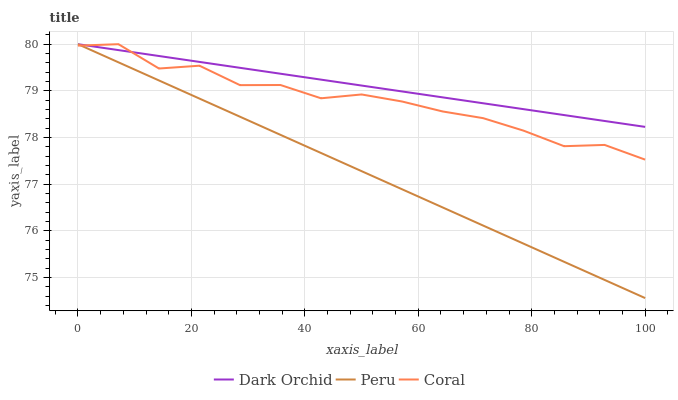Does Peru have the minimum area under the curve?
Answer yes or no. Yes. Does Dark Orchid have the maximum area under the curve?
Answer yes or no. Yes. Does Dark Orchid have the minimum area under the curve?
Answer yes or no. No. Does Peru have the maximum area under the curve?
Answer yes or no. No. Is Dark Orchid the smoothest?
Answer yes or no. Yes. Is Coral the roughest?
Answer yes or no. Yes. Is Peru the smoothest?
Answer yes or no. No. Is Peru the roughest?
Answer yes or no. No. Does Peru have the lowest value?
Answer yes or no. Yes. Does Dark Orchid have the lowest value?
Answer yes or no. No. Does Dark Orchid have the highest value?
Answer yes or no. Yes. Does Dark Orchid intersect Peru?
Answer yes or no. Yes. Is Dark Orchid less than Peru?
Answer yes or no. No. Is Dark Orchid greater than Peru?
Answer yes or no. No. 